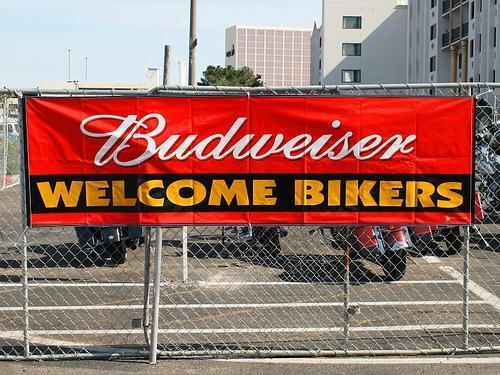How many signs?
Give a very brief answer. 1. 